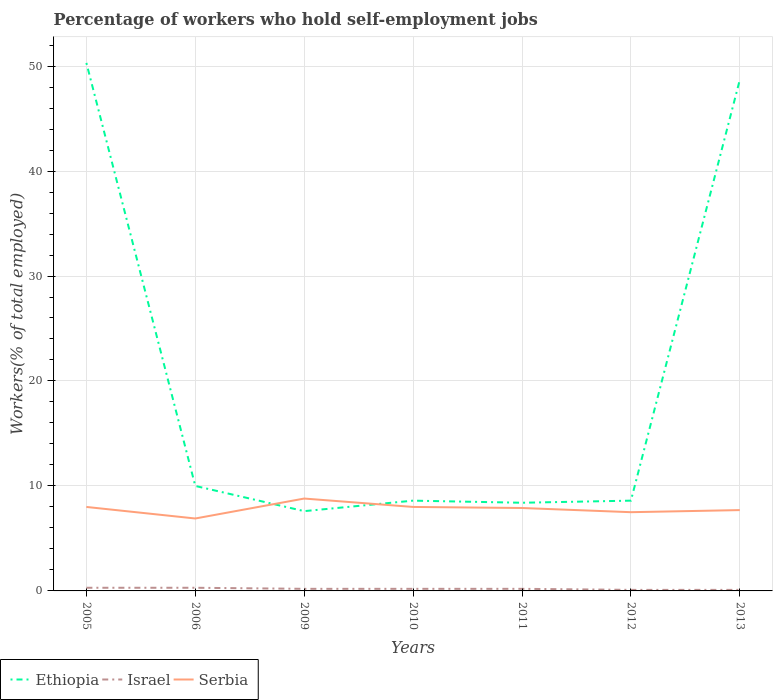How many different coloured lines are there?
Ensure brevity in your answer.  3. Does the line corresponding to Ethiopia intersect with the line corresponding to Israel?
Your answer should be very brief. No. Across all years, what is the maximum percentage of self-employed workers in Ethiopia?
Keep it short and to the point. 7.6. What is the total percentage of self-employed workers in Ethiopia in the graph?
Keep it short and to the point. 1.4. What is the difference between the highest and the second highest percentage of self-employed workers in Israel?
Your answer should be compact. 0.2. What is the difference between the highest and the lowest percentage of self-employed workers in Israel?
Make the answer very short. 2. How many years are there in the graph?
Provide a short and direct response. 7. Where does the legend appear in the graph?
Provide a succinct answer. Bottom left. How are the legend labels stacked?
Ensure brevity in your answer.  Horizontal. What is the title of the graph?
Your answer should be very brief. Percentage of workers who hold self-employment jobs. What is the label or title of the Y-axis?
Offer a very short reply. Workers(% of total employed). What is the Workers(% of total employed) in Ethiopia in 2005?
Give a very brief answer. 50.3. What is the Workers(% of total employed) of Israel in 2005?
Give a very brief answer. 0.3. What is the Workers(% of total employed) of Serbia in 2005?
Ensure brevity in your answer.  8. What is the Workers(% of total employed) of Ethiopia in 2006?
Give a very brief answer. 10. What is the Workers(% of total employed) in Israel in 2006?
Ensure brevity in your answer.  0.3. What is the Workers(% of total employed) of Serbia in 2006?
Keep it short and to the point. 6.9. What is the Workers(% of total employed) of Ethiopia in 2009?
Your answer should be very brief. 7.6. What is the Workers(% of total employed) of Israel in 2009?
Provide a short and direct response. 0.2. What is the Workers(% of total employed) in Serbia in 2009?
Offer a very short reply. 8.8. What is the Workers(% of total employed) in Ethiopia in 2010?
Offer a very short reply. 8.6. What is the Workers(% of total employed) of Israel in 2010?
Offer a very short reply. 0.2. What is the Workers(% of total employed) in Ethiopia in 2011?
Keep it short and to the point. 8.4. What is the Workers(% of total employed) of Israel in 2011?
Keep it short and to the point. 0.2. What is the Workers(% of total employed) in Serbia in 2011?
Offer a very short reply. 7.9. What is the Workers(% of total employed) of Ethiopia in 2012?
Your response must be concise. 8.6. What is the Workers(% of total employed) of Israel in 2012?
Your answer should be very brief. 0.1. What is the Workers(% of total employed) of Ethiopia in 2013?
Your answer should be very brief. 48.7. What is the Workers(% of total employed) of Israel in 2013?
Offer a terse response. 0.1. What is the Workers(% of total employed) in Serbia in 2013?
Ensure brevity in your answer.  7.7. Across all years, what is the maximum Workers(% of total employed) in Ethiopia?
Keep it short and to the point. 50.3. Across all years, what is the maximum Workers(% of total employed) of Israel?
Offer a very short reply. 0.3. Across all years, what is the maximum Workers(% of total employed) in Serbia?
Provide a short and direct response. 8.8. Across all years, what is the minimum Workers(% of total employed) in Ethiopia?
Provide a succinct answer. 7.6. Across all years, what is the minimum Workers(% of total employed) of Israel?
Ensure brevity in your answer.  0.1. Across all years, what is the minimum Workers(% of total employed) in Serbia?
Keep it short and to the point. 6.9. What is the total Workers(% of total employed) of Ethiopia in the graph?
Ensure brevity in your answer.  142.2. What is the total Workers(% of total employed) of Serbia in the graph?
Provide a short and direct response. 54.8. What is the difference between the Workers(% of total employed) of Ethiopia in 2005 and that in 2006?
Keep it short and to the point. 40.3. What is the difference between the Workers(% of total employed) in Serbia in 2005 and that in 2006?
Make the answer very short. 1.1. What is the difference between the Workers(% of total employed) in Ethiopia in 2005 and that in 2009?
Your answer should be very brief. 42.7. What is the difference between the Workers(% of total employed) in Israel in 2005 and that in 2009?
Give a very brief answer. 0.1. What is the difference between the Workers(% of total employed) of Serbia in 2005 and that in 2009?
Provide a succinct answer. -0.8. What is the difference between the Workers(% of total employed) in Ethiopia in 2005 and that in 2010?
Offer a terse response. 41.7. What is the difference between the Workers(% of total employed) in Serbia in 2005 and that in 2010?
Offer a terse response. 0. What is the difference between the Workers(% of total employed) in Ethiopia in 2005 and that in 2011?
Your answer should be very brief. 41.9. What is the difference between the Workers(% of total employed) of Serbia in 2005 and that in 2011?
Your answer should be very brief. 0.1. What is the difference between the Workers(% of total employed) of Ethiopia in 2005 and that in 2012?
Your answer should be compact. 41.7. What is the difference between the Workers(% of total employed) of Israel in 2005 and that in 2012?
Ensure brevity in your answer.  0.2. What is the difference between the Workers(% of total employed) of Serbia in 2005 and that in 2013?
Make the answer very short. 0.3. What is the difference between the Workers(% of total employed) of Serbia in 2006 and that in 2009?
Make the answer very short. -1.9. What is the difference between the Workers(% of total employed) of Serbia in 2006 and that in 2011?
Give a very brief answer. -1. What is the difference between the Workers(% of total employed) in Israel in 2006 and that in 2012?
Offer a terse response. 0.2. What is the difference between the Workers(% of total employed) in Ethiopia in 2006 and that in 2013?
Provide a short and direct response. -38.7. What is the difference between the Workers(% of total employed) in Israel in 2006 and that in 2013?
Your answer should be compact. 0.2. What is the difference between the Workers(% of total employed) in Serbia in 2009 and that in 2010?
Keep it short and to the point. 0.8. What is the difference between the Workers(% of total employed) in Israel in 2009 and that in 2011?
Your answer should be very brief. 0. What is the difference between the Workers(% of total employed) of Serbia in 2009 and that in 2011?
Your answer should be very brief. 0.9. What is the difference between the Workers(% of total employed) in Ethiopia in 2009 and that in 2012?
Your answer should be compact. -1. What is the difference between the Workers(% of total employed) of Serbia in 2009 and that in 2012?
Your answer should be compact. 1.3. What is the difference between the Workers(% of total employed) of Ethiopia in 2009 and that in 2013?
Give a very brief answer. -41.1. What is the difference between the Workers(% of total employed) in Israel in 2009 and that in 2013?
Your answer should be very brief. 0.1. What is the difference between the Workers(% of total employed) of Serbia in 2009 and that in 2013?
Keep it short and to the point. 1.1. What is the difference between the Workers(% of total employed) of Ethiopia in 2010 and that in 2011?
Offer a very short reply. 0.2. What is the difference between the Workers(% of total employed) in Ethiopia in 2010 and that in 2012?
Make the answer very short. 0. What is the difference between the Workers(% of total employed) in Serbia in 2010 and that in 2012?
Offer a very short reply. 0.5. What is the difference between the Workers(% of total employed) of Ethiopia in 2010 and that in 2013?
Your response must be concise. -40.1. What is the difference between the Workers(% of total employed) of Serbia in 2011 and that in 2012?
Keep it short and to the point. 0.4. What is the difference between the Workers(% of total employed) in Ethiopia in 2011 and that in 2013?
Keep it short and to the point. -40.3. What is the difference between the Workers(% of total employed) in Ethiopia in 2012 and that in 2013?
Give a very brief answer. -40.1. What is the difference between the Workers(% of total employed) of Israel in 2012 and that in 2013?
Make the answer very short. 0. What is the difference between the Workers(% of total employed) of Serbia in 2012 and that in 2013?
Provide a succinct answer. -0.2. What is the difference between the Workers(% of total employed) in Ethiopia in 2005 and the Workers(% of total employed) in Serbia in 2006?
Your response must be concise. 43.4. What is the difference between the Workers(% of total employed) of Ethiopia in 2005 and the Workers(% of total employed) of Israel in 2009?
Your answer should be very brief. 50.1. What is the difference between the Workers(% of total employed) of Ethiopia in 2005 and the Workers(% of total employed) of Serbia in 2009?
Provide a succinct answer. 41.5. What is the difference between the Workers(% of total employed) of Israel in 2005 and the Workers(% of total employed) of Serbia in 2009?
Your answer should be compact. -8.5. What is the difference between the Workers(% of total employed) of Ethiopia in 2005 and the Workers(% of total employed) of Israel in 2010?
Provide a short and direct response. 50.1. What is the difference between the Workers(% of total employed) in Ethiopia in 2005 and the Workers(% of total employed) in Serbia in 2010?
Provide a short and direct response. 42.3. What is the difference between the Workers(% of total employed) in Israel in 2005 and the Workers(% of total employed) in Serbia in 2010?
Offer a terse response. -7.7. What is the difference between the Workers(% of total employed) of Ethiopia in 2005 and the Workers(% of total employed) of Israel in 2011?
Make the answer very short. 50.1. What is the difference between the Workers(% of total employed) in Ethiopia in 2005 and the Workers(% of total employed) in Serbia in 2011?
Your response must be concise. 42.4. What is the difference between the Workers(% of total employed) of Israel in 2005 and the Workers(% of total employed) of Serbia in 2011?
Make the answer very short. -7.6. What is the difference between the Workers(% of total employed) of Ethiopia in 2005 and the Workers(% of total employed) of Israel in 2012?
Offer a very short reply. 50.2. What is the difference between the Workers(% of total employed) in Ethiopia in 2005 and the Workers(% of total employed) in Serbia in 2012?
Make the answer very short. 42.8. What is the difference between the Workers(% of total employed) in Ethiopia in 2005 and the Workers(% of total employed) in Israel in 2013?
Offer a very short reply. 50.2. What is the difference between the Workers(% of total employed) of Ethiopia in 2005 and the Workers(% of total employed) of Serbia in 2013?
Your answer should be very brief. 42.6. What is the difference between the Workers(% of total employed) of Ethiopia in 2006 and the Workers(% of total employed) of Serbia in 2009?
Your answer should be very brief. 1.2. What is the difference between the Workers(% of total employed) of Ethiopia in 2006 and the Workers(% of total employed) of Serbia in 2010?
Provide a short and direct response. 2. What is the difference between the Workers(% of total employed) of Israel in 2006 and the Workers(% of total employed) of Serbia in 2010?
Your response must be concise. -7.7. What is the difference between the Workers(% of total employed) of Ethiopia in 2006 and the Workers(% of total employed) of Israel in 2011?
Your answer should be compact. 9.8. What is the difference between the Workers(% of total employed) in Israel in 2006 and the Workers(% of total employed) in Serbia in 2011?
Ensure brevity in your answer.  -7.6. What is the difference between the Workers(% of total employed) in Ethiopia in 2006 and the Workers(% of total employed) in Israel in 2013?
Keep it short and to the point. 9.9. What is the difference between the Workers(% of total employed) of Ethiopia in 2006 and the Workers(% of total employed) of Serbia in 2013?
Your response must be concise. 2.3. What is the difference between the Workers(% of total employed) in Ethiopia in 2009 and the Workers(% of total employed) in Israel in 2010?
Your answer should be compact. 7.4. What is the difference between the Workers(% of total employed) of Ethiopia in 2009 and the Workers(% of total employed) of Serbia in 2010?
Ensure brevity in your answer.  -0.4. What is the difference between the Workers(% of total employed) in Ethiopia in 2009 and the Workers(% of total employed) in Israel in 2012?
Provide a short and direct response. 7.5. What is the difference between the Workers(% of total employed) in Ethiopia in 2009 and the Workers(% of total employed) in Serbia in 2012?
Your answer should be very brief. 0.1. What is the difference between the Workers(% of total employed) of Israel in 2009 and the Workers(% of total employed) of Serbia in 2012?
Ensure brevity in your answer.  -7.3. What is the difference between the Workers(% of total employed) of Ethiopia in 2009 and the Workers(% of total employed) of Israel in 2013?
Make the answer very short. 7.5. What is the difference between the Workers(% of total employed) in Israel in 2009 and the Workers(% of total employed) in Serbia in 2013?
Your response must be concise. -7.5. What is the difference between the Workers(% of total employed) of Ethiopia in 2010 and the Workers(% of total employed) of Israel in 2011?
Offer a very short reply. 8.4. What is the difference between the Workers(% of total employed) of Ethiopia in 2010 and the Workers(% of total employed) of Serbia in 2013?
Provide a short and direct response. 0.9. What is the difference between the Workers(% of total employed) of Israel in 2010 and the Workers(% of total employed) of Serbia in 2013?
Keep it short and to the point. -7.5. What is the difference between the Workers(% of total employed) in Ethiopia in 2011 and the Workers(% of total employed) in Israel in 2012?
Give a very brief answer. 8.3. What is the difference between the Workers(% of total employed) in Ethiopia in 2011 and the Workers(% of total employed) in Serbia in 2012?
Your answer should be compact. 0.9. What is the difference between the Workers(% of total employed) in Israel in 2011 and the Workers(% of total employed) in Serbia in 2013?
Your response must be concise. -7.5. What is the difference between the Workers(% of total employed) of Ethiopia in 2012 and the Workers(% of total employed) of Serbia in 2013?
Your response must be concise. 0.9. What is the average Workers(% of total employed) of Ethiopia per year?
Your answer should be compact. 20.31. What is the average Workers(% of total employed) in Serbia per year?
Your response must be concise. 7.83. In the year 2005, what is the difference between the Workers(% of total employed) of Ethiopia and Workers(% of total employed) of Israel?
Keep it short and to the point. 50. In the year 2005, what is the difference between the Workers(% of total employed) of Ethiopia and Workers(% of total employed) of Serbia?
Your response must be concise. 42.3. In the year 2006, what is the difference between the Workers(% of total employed) in Ethiopia and Workers(% of total employed) in Serbia?
Keep it short and to the point. 3.1. In the year 2006, what is the difference between the Workers(% of total employed) of Israel and Workers(% of total employed) of Serbia?
Keep it short and to the point. -6.6. In the year 2009, what is the difference between the Workers(% of total employed) in Ethiopia and Workers(% of total employed) in Serbia?
Offer a very short reply. -1.2. In the year 2010, what is the difference between the Workers(% of total employed) of Ethiopia and Workers(% of total employed) of Serbia?
Your answer should be compact. 0.6. In the year 2010, what is the difference between the Workers(% of total employed) in Israel and Workers(% of total employed) in Serbia?
Your answer should be very brief. -7.8. In the year 2011, what is the difference between the Workers(% of total employed) in Ethiopia and Workers(% of total employed) in Israel?
Provide a short and direct response. 8.2. In the year 2011, what is the difference between the Workers(% of total employed) in Ethiopia and Workers(% of total employed) in Serbia?
Provide a short and direct response. 0.5. In the year 2013, what is the difference between the Workers(% of total employed) of Ethiopia and Workers(% of total employed) of Israel?
Provide a succinct answer. 48.6. In the year 2013, what is the difference between the Workers(% of total employed) of Israel and Workers(% of total employed) of Serbia?
Keep it short and to the point. -7.6. What is the ratio of the Workers(% of total employed) of Ethiopia in 2005 to that in 2006?
Provide a succinct answer. 5.03. What is the ratio of the Workers(% of total employed) of Israel in 2005 to that in 2006?
Your answer should be compact. 1. What is the ratio of the Workers(% of total employed) of Serbia in 2005 to that in 2006?
Provide a succinct answer. 1.16. What is the ratio of the Workers(% of total employed) in Ethiopia in 2005 to that in 2009?
Your answer should be very brief. 6.62. What is the ratio of the Workers(% of total employed) in Ethiopia in 2005 to that in 2010?
Provide a succinct answer. 5.85. What is the ratio of the Workers(% of total employed) of Israel in 2005 to that in 2010?
Give a very brief answer. 1.5. What is the ratio of the Workers(% of total employed) in Ethiopia in 2005 to that in 2011?
Offer a terse response. 5.99. What is the ratio of the Workers(% of total employed) in Israel in 2005 to that in 2011?
Make the answer very short. 1.5. What is the ratio of the Workers(% of total employed) of Serbia in 2005 to that in 2011?
Your answer should be very brief. 1.01. What is the ratio of the Workers(% of total employed) of Ethiopia in 2005 to that in 2012?
Your answer should be compact. 5.85. What is the ratio of the Workers(% of total employed) of Israel in 2005 to that in 2012?
Make the answer very short. 3. What is the ratio of the Workers(% of total employed) in Serbia in 2005 to that in 2012?
Provide a short and direct response. 1.07. What is the ratio of the Workers(% of total employed) in Ethiopia in 2005 to that in 2013?
Provide a short and direct response. 1.03. What is the ratio of the Workers(% of total employed) of Israel in 2005 to that in 2013?
Offer a very short reply. 3. What is the ratio of the Workers(% of total employed) of Serbia in 2005 to that in 2013?
Keep it short and to the point. 1.04. What is the ratio of the Workers(% of total employed) in Ethiopia in 2006 to that in 2009?
Provide a short and direct response. 1.32. What is the ratio of the Workers(% of total employed) of Israel in 2006 to that in 2009?
Provide a succinct answer. 1.5. What is the ratio of the Workers(% of total employed) in Serbia in 2006 to that in 2009?
Keep it short and to the point. 0.78. What is the ratio of the Workers(% of total employed) in Ethiopia in 2006 to that in 2010?
Provide a succinct answer. 1.16. What is the ratio of the Workers(% of total employed) in Serbia in 2006 to that in 2010?
Offer a terse response. 0.86. What is the ratio of the Workers(% of total employed) in Ethiopia in 2006 to that in 2011?
Provide a succinct answer. 1.19. What is the ratio of the Workers(% of total employed) of Serbia in 2006 to that in 2011?
Keep it short and to the point. 0.87. What is the ratio of the Workers(% of total employed) in Ethiopia in 2006 to that in 2012?
Offer a terse response. 1.16. What is the ratio of the Workers(% of total employed) in Ethiopia in 2006 to that in 2013?
Make the answer very short. 0.21. What is the ratio of the Workers(% of total employed) in Israel in 2006 to that in 2013?
Ensure brevity in your answer.  3. What is the ratio of the Workers(% of total employed) of Serbia in 2006 to that in 2013?
Offer a very short reply. 0.9. What is the ratio of the Workers(% of total employed) of Ethiopia in 2009 to that in 2010?
Provide a short and direct response. 0.88. What is the ratio of the Workers(% of total employed) in Serbia in 2009 to that in 2010?
Your answer should be very brief. 1.1. What is the ratio of the Workers(% of total employed) of Ethiopia in 2009 to that in 2011?
Give a very brief answer. 0.9. What is the ratio of the Workers(% of total employed) in Israel in 2009 to that in 2011?
Offer a terse response. 1. What is the ratio of the Workers(% of total employed) in Serbia in 2009 to that in 2011?
Ensure brevity in your answer.  1.11. What is the ratio of the Workers(% of total employed) of Ethiopia in 2009 to that in 2012?
Provide a short and direct response. 0.88. What is the ratio of the Workers(% of total employed) of Serbia in 2009 to that in 2012?
Offer a terse response. 1.17. What is the ratio of the Workers(% of total employed) of Ethiopia in 2009 to that in 2013?
Give a very brief answer. 0.16. What is the ratio of the Workers(% of total employed) in Serbia in 2009 to that in 2013?
Your answer should be compact. 1.14. What is the ratio of the Workers(% of total employed) in Ethiopia in 2010 to that in 2011?
Make the answer very short. 1.02. What is the ratio of the Workers(% of total employed) of Israel in 2010 to that in 2011?
Your response must be concise. 1. What is the ratio of the Workers(% of total employed) in Serbia in 2010 to that in 2011?
Keep it short and to the point. 1.01. What is the ratio of the Workers(% of total employed) in Ethiopia in 2010 to that in 2012?
Make the answer very short. 1. What is the ratio of the Workers(% of total employed) in Israel in 2010 to that in 2012?
Provide a succinct answer. 2. What is the ratio of the Workers(% of total employed) of Serbia in 2010 to that in 2012?
Your answer should be very brief. 1.07. What is the ratio of the Workers(% of total employed) of Ethiopia in 2010 to that in 2013?
Your response must be concise. 0.18. What is the ratio of the Workers(% of total employed) in Israel in 2010 to that in 2013?
Give a very brief answer. 2. What is the ratio of the Workers(% of total employed) of Serbia in 2010 to that in 2013?
Offer a very short reply. 1.04. What is the ratio of the Workers(% of total employed) of Ethiopia in 2011 to that in 2012?
Provide a succinct answer. 0.98. What is the ratio of the Workers(% of total employed) in Serbia in 2011 to that in 2012?
Offer a very short reply. 1.05. What is the ratio of the Workers(% of total employed) of Ethiopia in 2011 to that in 2013?
Offer a very short reply. 0.17. What is the ratio of the Workers(% of total employed) of Israel in 2011 to that in 2013?
Ensure brevity in your answer.  2. What is the ratio of the Workers(% of total employed) in Ethiopia in 2012 to that in 2013?
Your answer should be very brief. 0.18. What is the difference between the highest and the second highest Workers(% of total employed) in Ethiopia?
Provide a succinct answer. 1.6. What is the difference between the highest and the second highest Workers(% of total employed) in Serbia?
Give a very brief answer. 0.8. What is the difference between the highest and the lowest Workers(% of total employed) in Ethiopia?
Your answer should be compact. 42.7. 